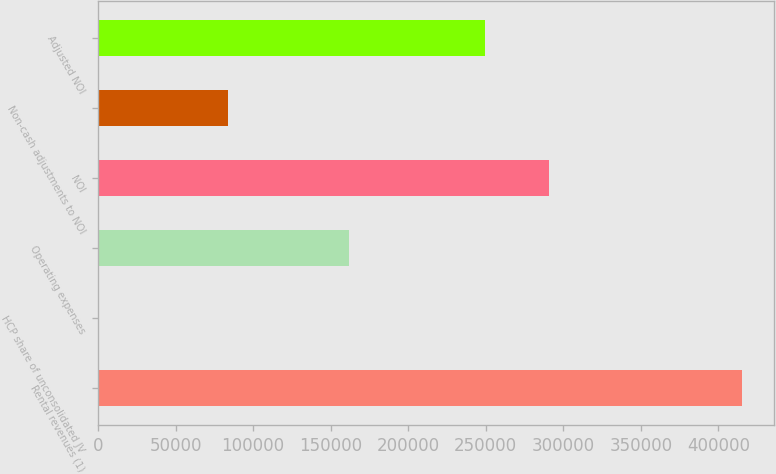<chart> <loc_0><loc_0><loc_500><loc_500><bar_chart><fcel>Rental revenues (1)<fcel>HCP share of unconsolidated JV<fcel>Operating expenses<fcel>NOI<fcel>Non-cash adjustments to NOI<fcel>Adjusted NOI<nl><fcel>415351<fcel>612<fcel>162054<fcel>291096<fcel>83559.8<fcel>249622<nl></chart> 